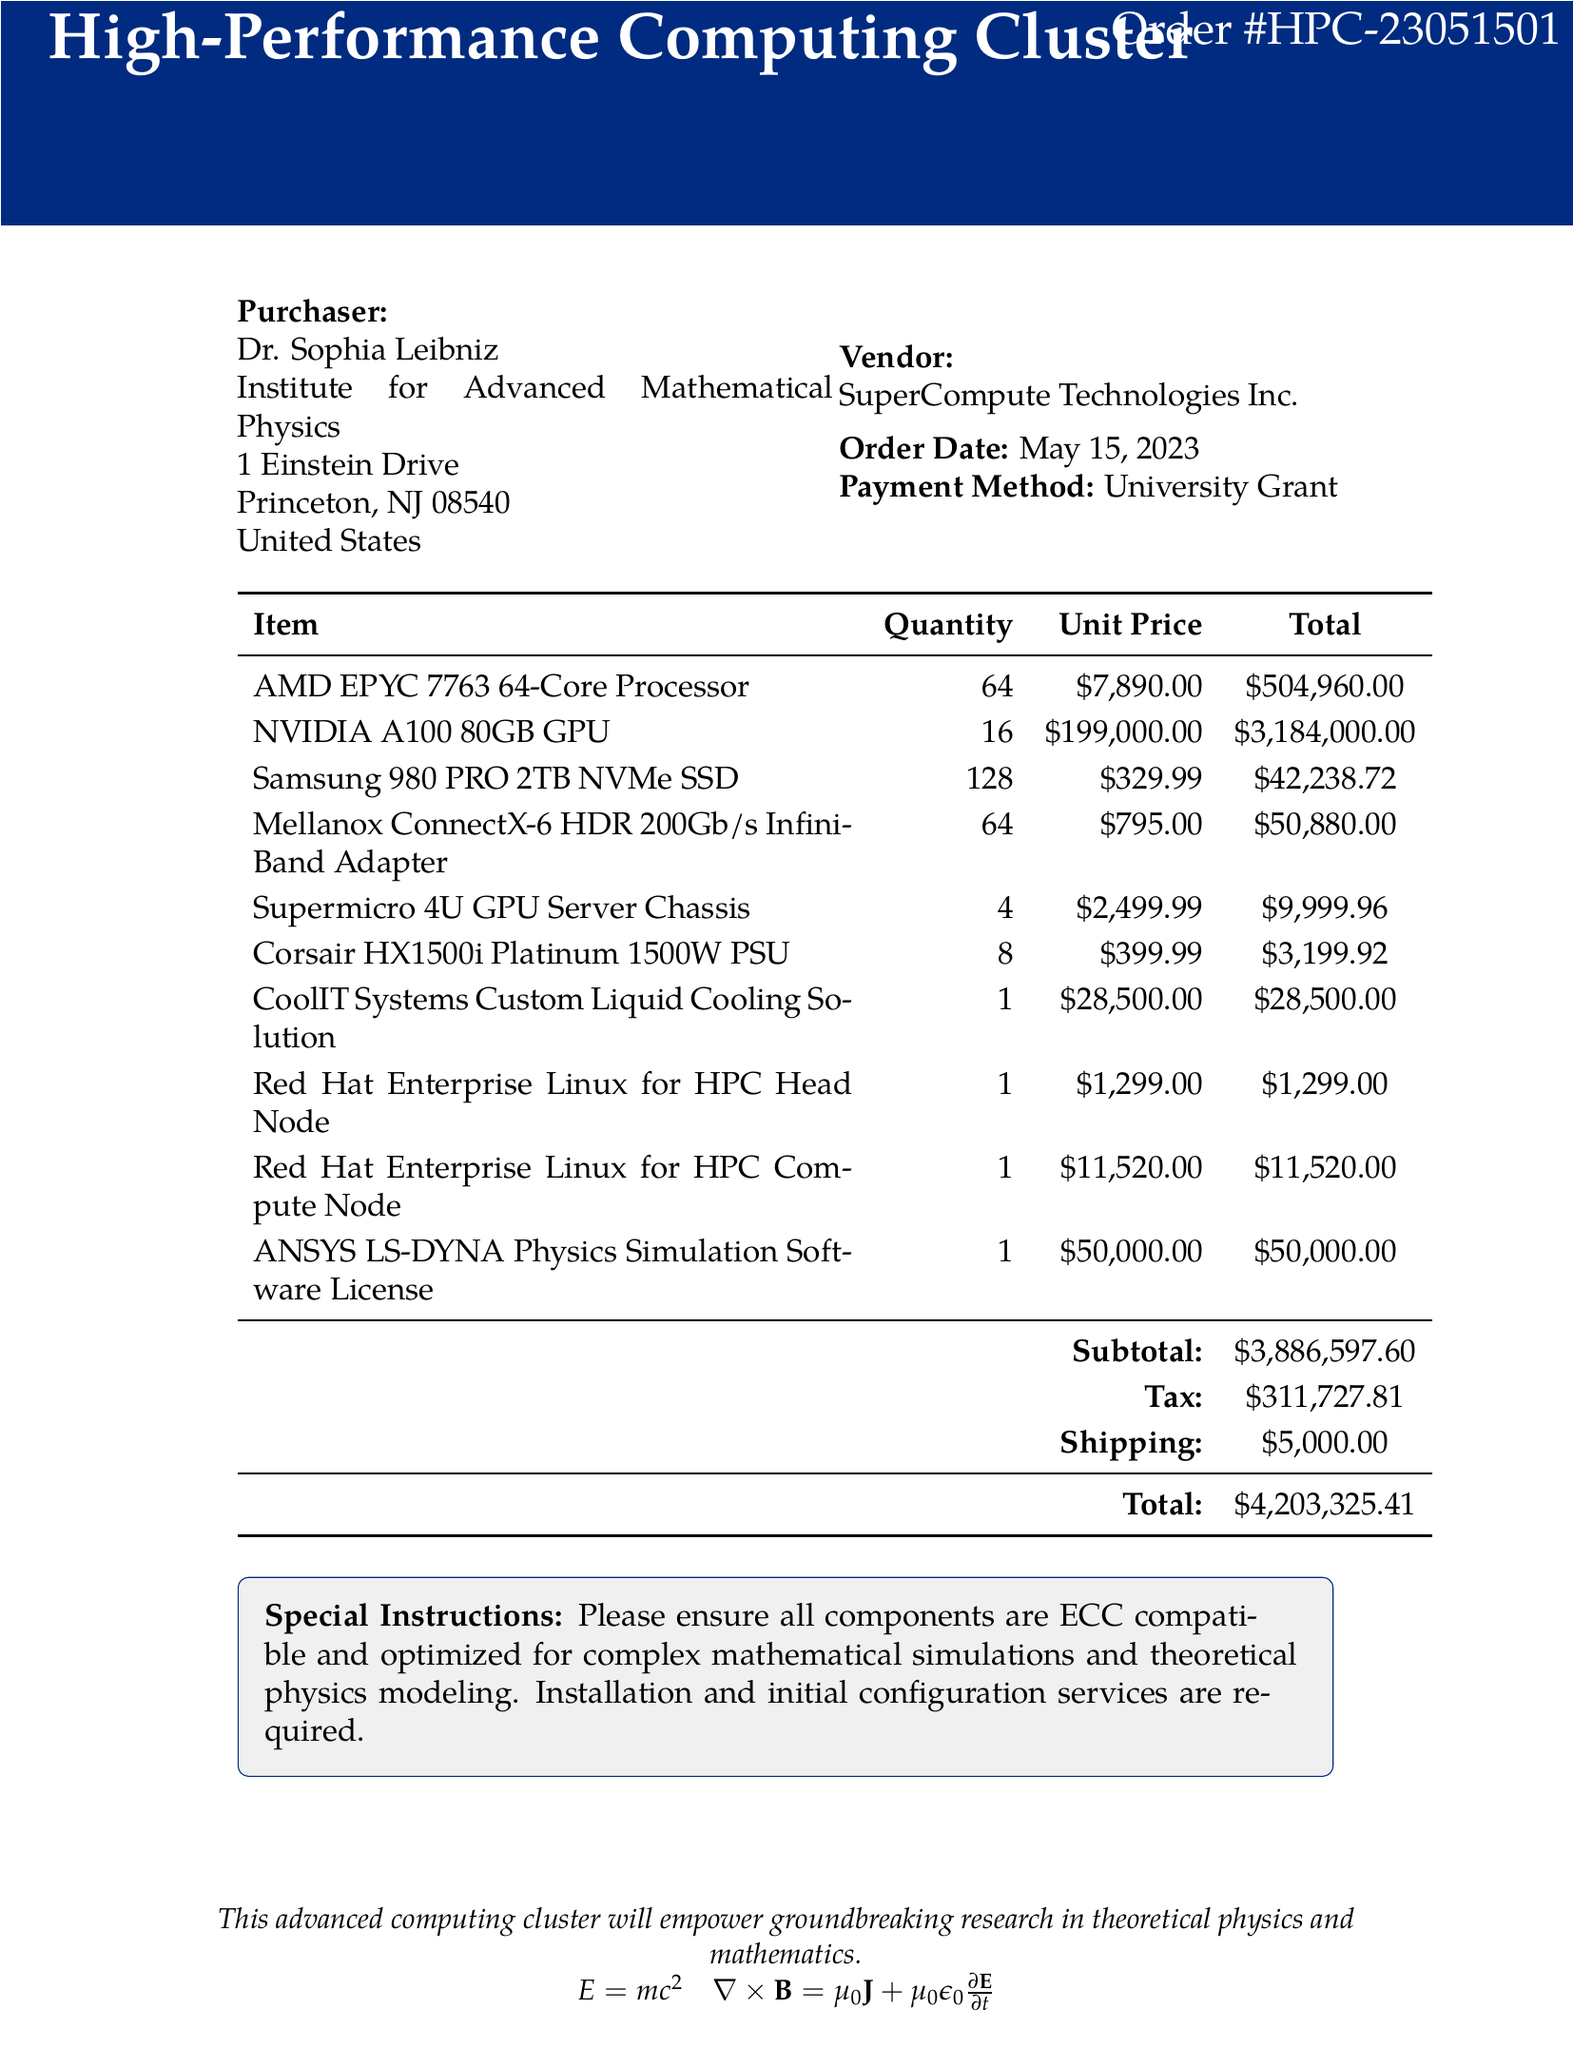What is the name of the purchaser? The purchaser's name is mentioned at the top of the document, indicating who made the purchase.
Answer: Dr. Sophia Leibniz How many NVIDIA A100 GPUs were ordered? The order lists the quantity of NVIDIA A100 GPUs under the item section.
Answer: 16 What is the subtotal of the order? The subtotal is calculated as the sum of all item total prices before tax and shipping, presented in the document.
Answer: $3,886,597.60 Who is the vendor? The vendor's name is explicitly stated in the document near the purchaser's information.
Answer: SuperCompute Technologies Inc What is the total cost including tax and shipping? The total cost is the final amount after adding the subtotal, tax, and shipping, compiled at the bottom of the document.
Answer: $4,203,325.41 What is the quantity of Samsung 980 PRO NVMe SSDs ordered? The document specifies the ordered quantity for each item, including Samsung SSDs.
Answer: 128 What special instructions were provided with the order? The special instructions detail the requirements for the components and services requested alongside the purchase.
Answer: Please ensure all components are ECC compatible and optimized for complex mathematical simulations and theoretical physics modeling. Installation and initial configuration services are required What payment method was used for this purchase? The payment method specifies how the transaction was financed, listed in the document near the order date.
Answer: University Grant What is the quantity of Supermicro 4U GPU Server Chassis purchased? The document specifies how many units of each server chassis were ordered.
Answer: 4 What software license was included in the order? The document includes details of the software licenses that were part of the purchase, showcasing necessary tools for the HPC cluster.
Answer: ANSYS LS-DYNA Physics Simulation Software License 